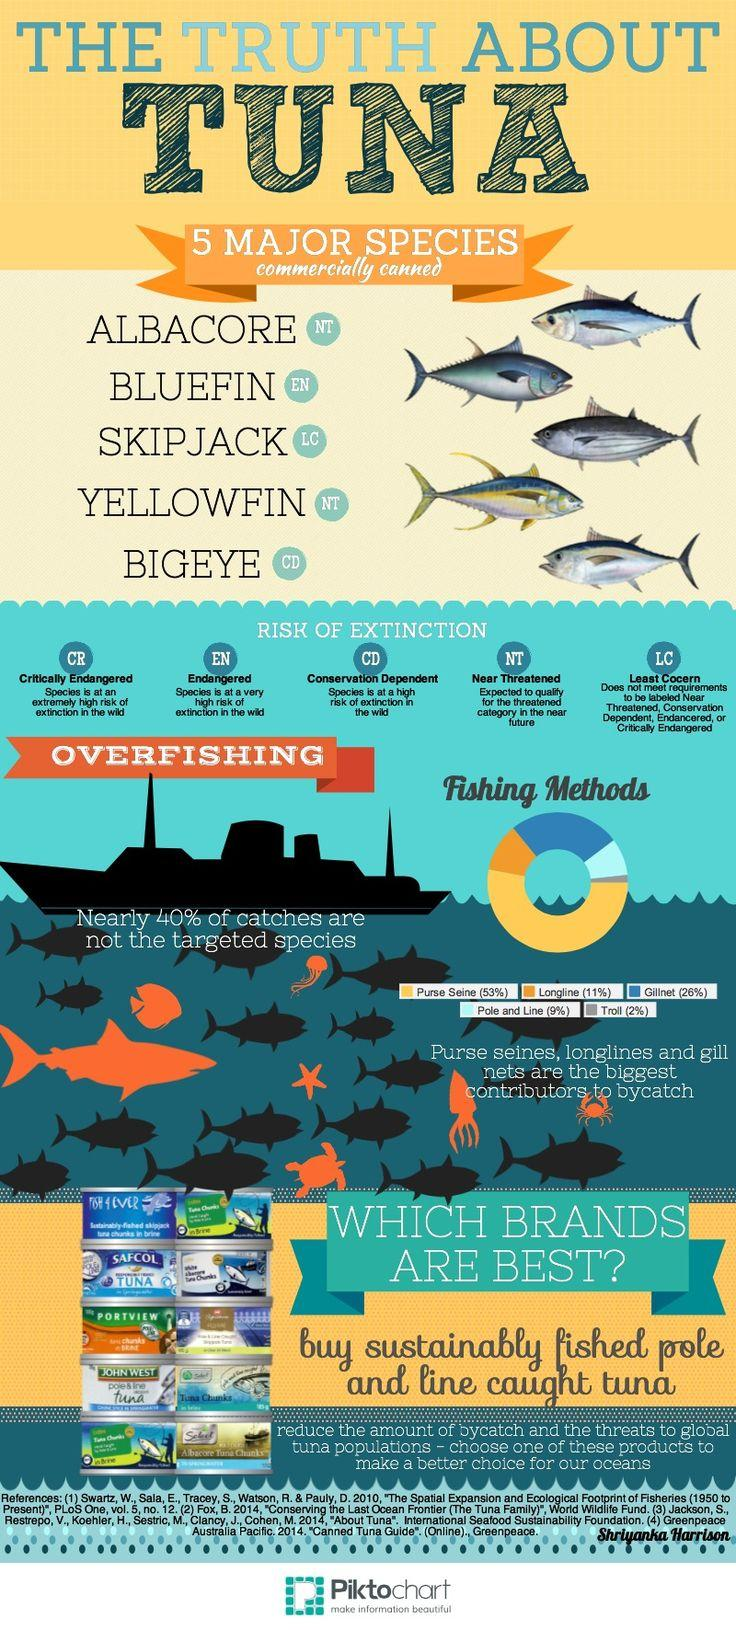Outline some significant characteristics in this image. The number of categories or groups into which a species can be divided depends on the level of risk of extinction. For example, if the risk of extinction is low, the species may be divided into only a few categories or groups, while if the risk is high, the species may be divided into a larger number of categories or groups. Sixty percent of the catches are targeted species. Gillnetting is the second most commonly used method of fishing, following behind netting. Yellowfin and Albacore tuna species are classified as near threatened according to the latest assessments. Purse seine fishing is the most commonly used method of fishing, according to a recent study. 